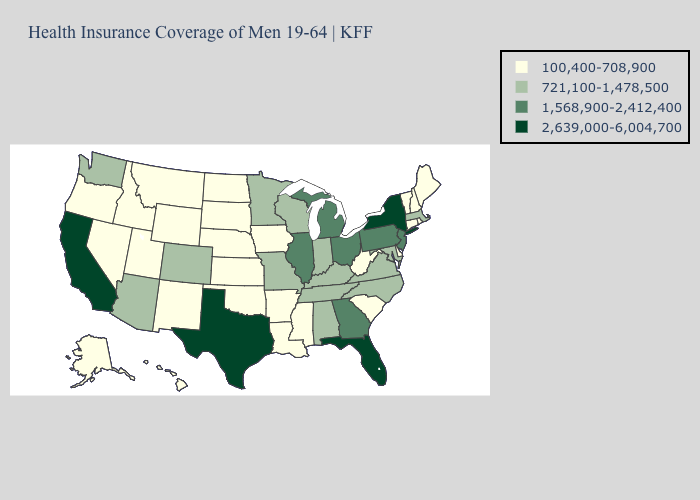What is the lowest value in the USA?
Quick response, please. 100,400-708,900. Does South Carolina have the highest value in the USA?
Keep it brief. No. What is the value of Missouri?
Give a very brief answer. 721,100-1,478,500. What is the lowest value in states that border Pennsylvania?
Give a very brief answer. 100,400-708,900. Does South Dakota have the same value as Mississippi?
Give a very brief answer. Yes. What is the highest value in the USA?
Answer briefly. 2,639,000-6,004,700. What is the value of West Virginia?
Write a very short answer. 100,400-708,900. Does Wisconsin have a higher value than California?
Answer briefly. No. What is the highest value in states that border California?
Short answer required. 721,100-1,478,500. Does Florida have the highest value in the USA?
Answer briefly. Yes. What is the value of Maryland?
Give a very brief answer. 721,100-1,478,500. Among the states that border Montana , which have the lowest value?
Quick response, please. Idaho, North Dakota, South Dakota, Wyoming. Does Ohio have the highest value in the USA?
Answer briefly. No. Does Kentucky have the lowest value in the South?
Short answer required. No. 